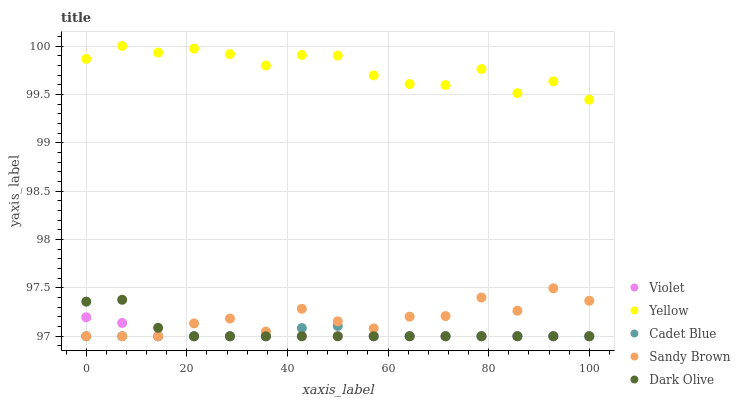Does Cadet Blue have the minimum area under the curve?
Answer yes or no. Yes. Does Yellow have the maximum area under the curve?
Answer yes or no. Yes. Does Sandy Brown have the minimum area under the curve?
Answer yes or no. No. Does Sandy Brown have the maximum area under the curve?
Answer yes or no. No. Is Violet the smoothest?
Answer yes or no. Yes. Is Sandy Brown the roughest?
Answer yes or no. Yes. Is Cadet Blue the smoothest?
Answer yes or no. No. Is Cadet Blue the roughest?
Answer yes or no. No. Does Dark Olive have the lowest value?
Answer yes or no. Yes. Does Yellow have the lowest value?
Answer yes or no. No. Does Yellow have the highest value?
Answer yes or no. Yes. Does Sandy Brown have the highest value?
Answer yes or no. No. Is Sandy Brown less than Yellow?
Answer yes or no. Yes. Is Yellow greater than Cadet Blue?
Answer yes or no. Yes. Does Cadet Blue intersect Violet?
Answer yes or no. Yes. Is Cadet Blue less than Violet?
Answer yes or no. No. Is Cadet Blue greater than Violet?
Answer yes or no. No. Does Sandy Brown intersect Yellow?
Answer yes or no. No. 